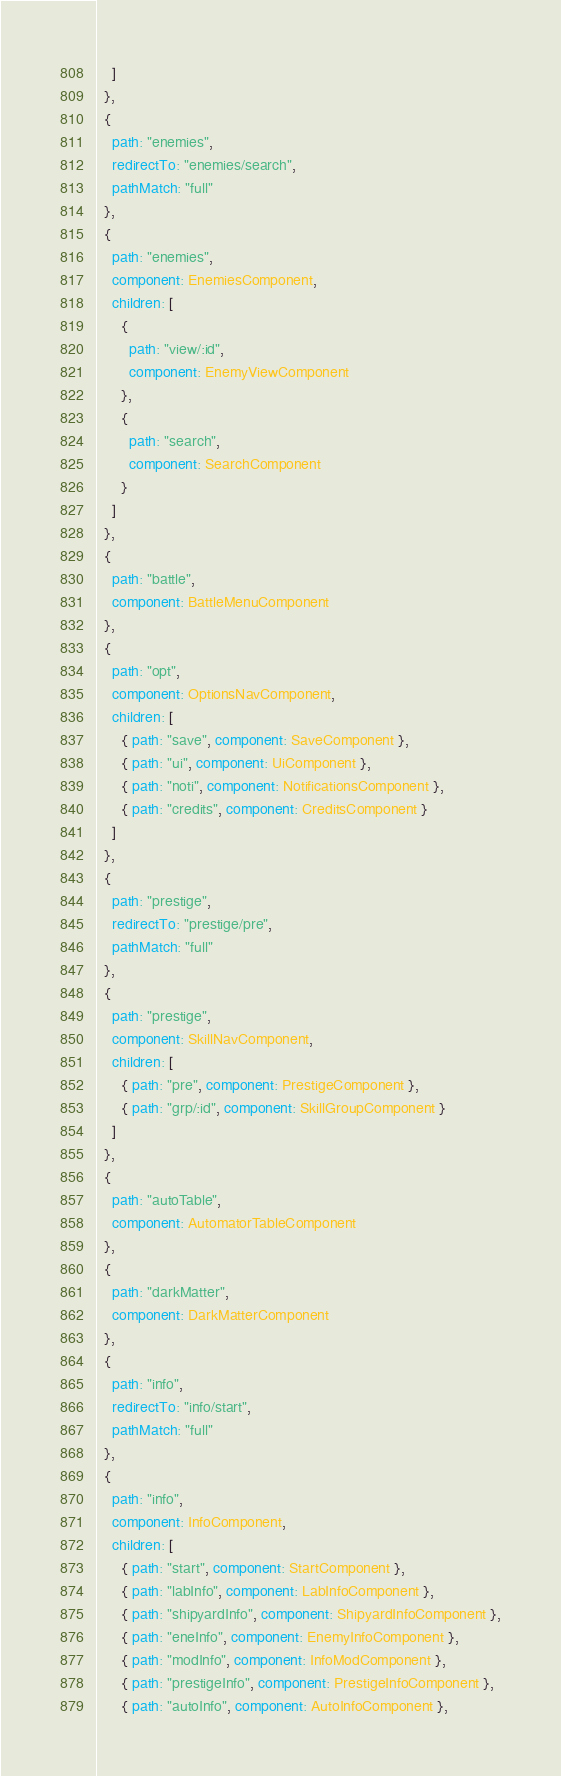<code> <loc_0><loc_0><loc_500><loc_500><_TypeScript_>    ]
  },
  {
    path: "enemies",
    redirectTo: "enemies/search",
    pathMatch: "full"
  },
  {
    path: "enemies",
    component: EnemiesComponent,
    children: [
      {
        path: "view/:id",
        component: EnemyViewComponent
      },
      {
        path: "search",
        component: SearchComponent
      }
    ]
  },
  {
    path: "battle",
    component: BattleMenuComponent
  },
  {
    path: "opt",
    component: OptionsNavComponent,
    children: [
      { path: "save", component: SaveComponent },
      { path: "ui", component: UiComponent },
      { path: "noti", component: NotificationsComponent },
      { path: "credits", component: CreditsComponent }
    ]
  },
  {
    path: "prestige",
    redirectTo: "prestige/pre",
    pathMatch: "full"
  },
  {
    path: "prestige",
    component: SkillNavComponent,
    children: [
      { path: "pre", component: PrestigeComponent },
      { path: "grp/:id", component: SkillGroupComponent }
    ]
  },
  {
    path: "autoTable",
    component: AutomatorTableComponent
  },
  {
    path: "darkMatter",
    component: DarkMatterComponent
  },
  {
    path: "info",
    redirectTo: "info/start",
    pathMatch: "full"
  },
  {
    path: "info",
    component: InfoComponent,
    children: [
      { path: "start", component: StartComponent },
      { path: "labInfo", component: LabInfoComponent },
      { path: "shipyardInfo", component: ShipyardInfoComponent },
      { path: "eneInfo", component: EnemyInfoComponent },
      { path: "modInfo", component: InfoModComponent },
      { path: "prestigeInfo", component: PrestigeInfoComponent },
      { path: "autoInfo", component: AutoInfoComponent },</code> 